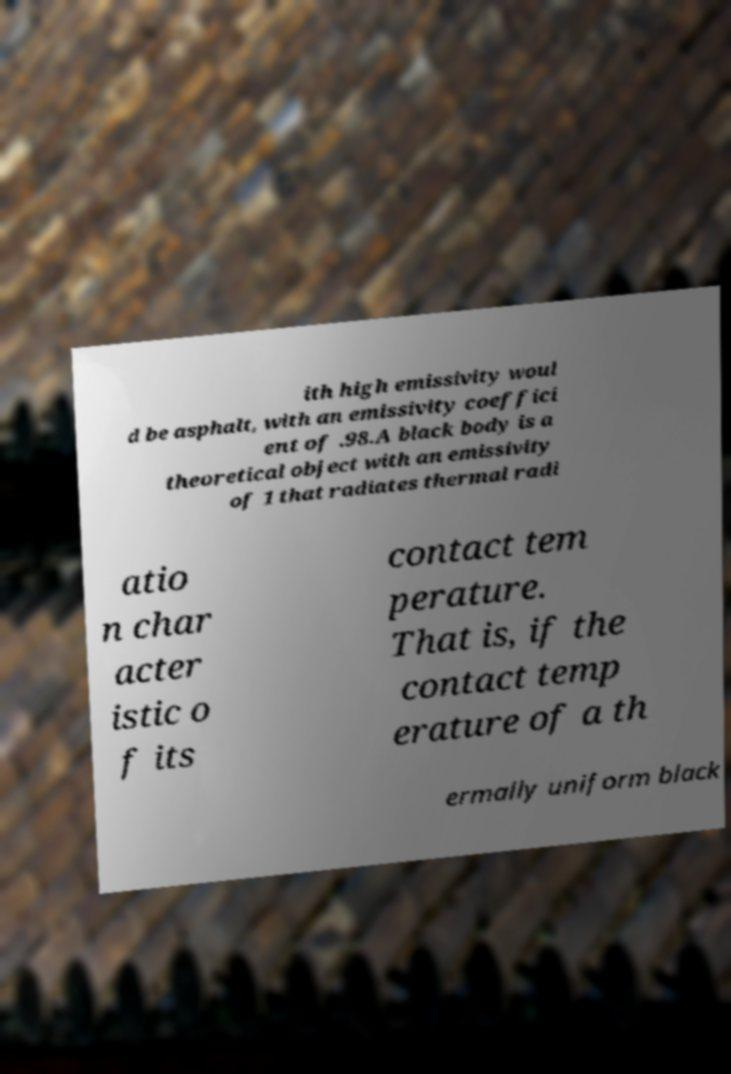What messages or text are displayed in this image? I need them in a readable, typed format. ith high emissivity woul d be asphalt, with an emissivity coeffici ent of .98.A black body is a theoretical object with an emissivity of 1 that radiates thermal radi atio n char acter istic o f its contact tem perature. That is, if the contact temp erature of a th ermally uniform black 